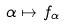<formula> <loc_0><loc_0><loc_500><loc_500>\alpha \mapsto f _ { \alpha }</formula> 